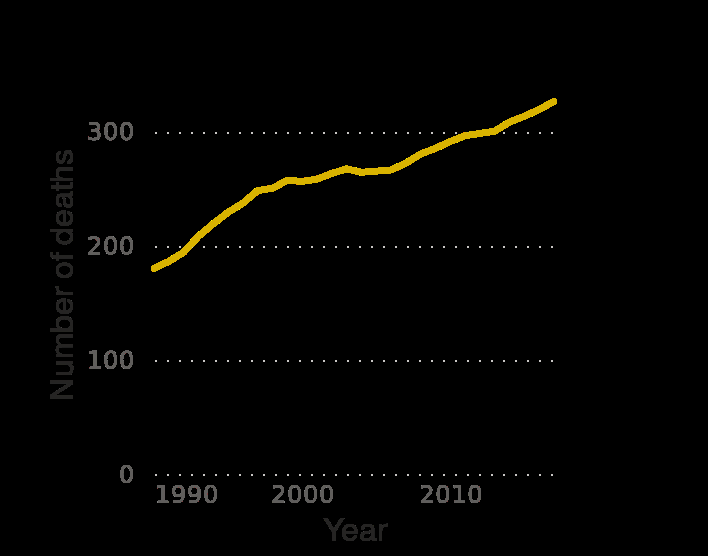<image>
What is the range of values on the y-axis? The y-axis has a linear scale with a range of 0 to 300. What is depicted on the x-axis of the chart? The x-axis of the chart represents the "Year." What is the name of the line chart? The line chart is named "Number of direct deaths from eating disorders worldwide from 1990 to 2017." 